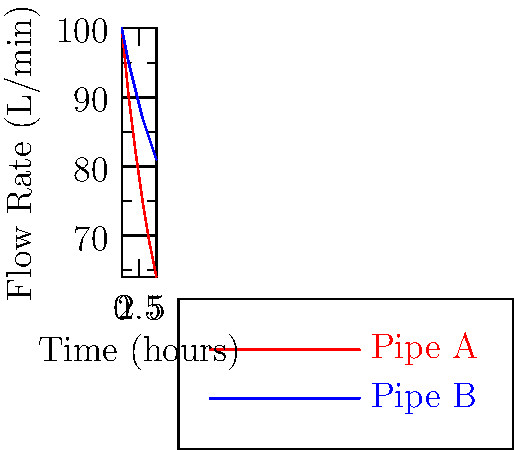As a data scientist analyzing water flow rates, you encounter the graph above showing flow rates through two different pipe configurations over time. If the initial flow rate for both pipes is 100 L/min, what is the difference in flow rate between Pipe A and Pipe B after 5 hours, rounded to the nearest whole number? Let's approach this step-by-step:

1. Identify the flow rates at t = 5 hours:
   - For Pipe A: 64 L/min
   - For Pipe B: 81 L/min

2. Calculate the difference:
   $$ \text{Difference} = \text{Flow rate}_B - \text{Flow rate}_A $$
   $$ = 81 \text{ L/min} - 64 \text{ L/min} = 17 \text{ L/min} $$

3. The question asks for the result rounded to the nearest whole number:
   17 L/min is already a whole number, so no rounding is necessary.

This analysis showcases how data visualization can quickly reveal differences in system behaviors over time, a common task in data science and engineering.
Answer: 17 L/min 